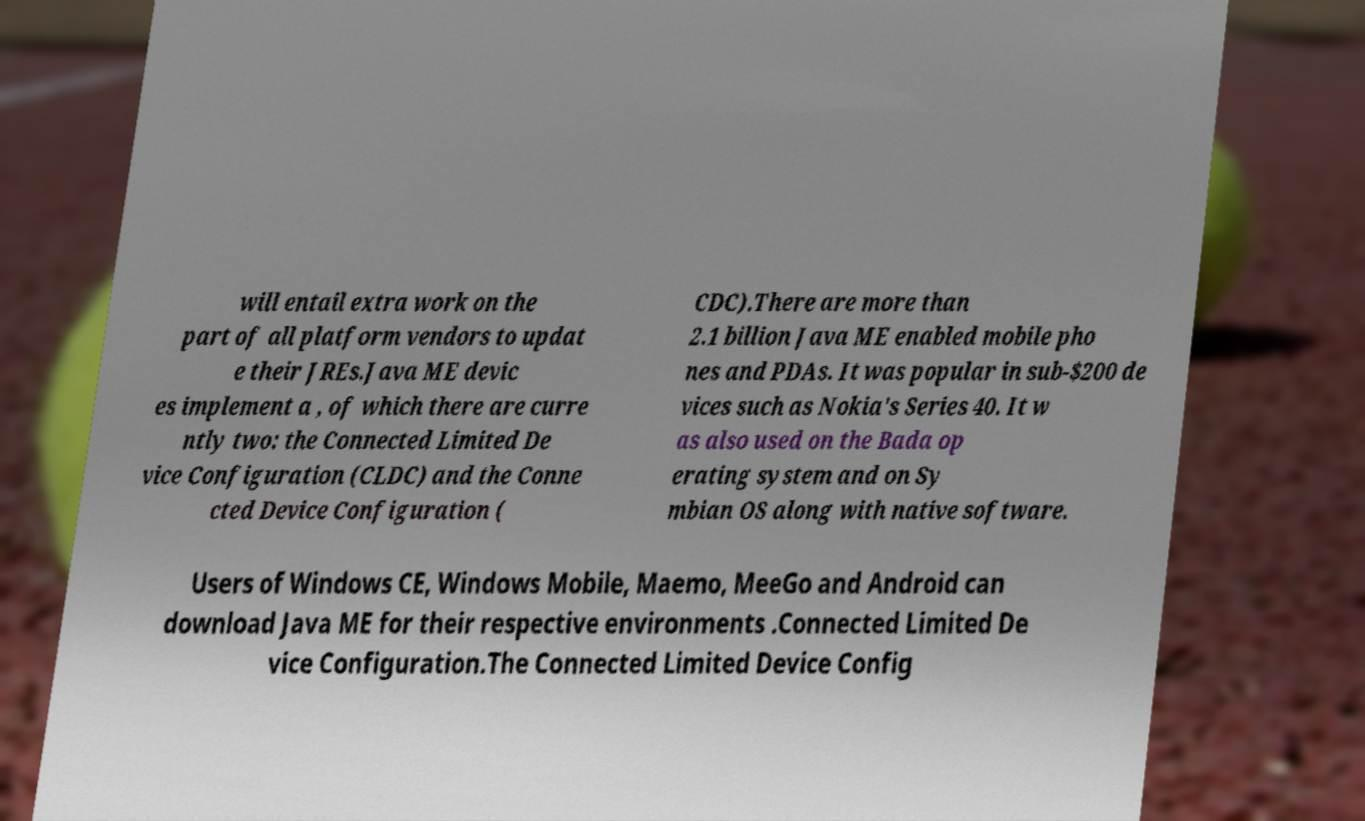Could you extract and type out the text from this image? will entail extra work on the part of all platform vendors to updat e their JREs.Java ME devic es implement a , of which there are curre ntly two: the Connected Limited De vice Configuration (CLDC) and the Conne cted Device Configuration ( CDC).There are more than 2.1 billion Java ME enabled mobile pho nes and PDAs. It was popular in sub-$200 de vices such as Nokia's Series 40. It w as also used on the Bada op erating system and on Sy mbian OS along with native software. Users of Windows CE, Windows Mobile, Maemo, MeeGo and Android can download Java ME for their respective environments .Connected Limited De vice Configuration.The Connected Limited Device Config 